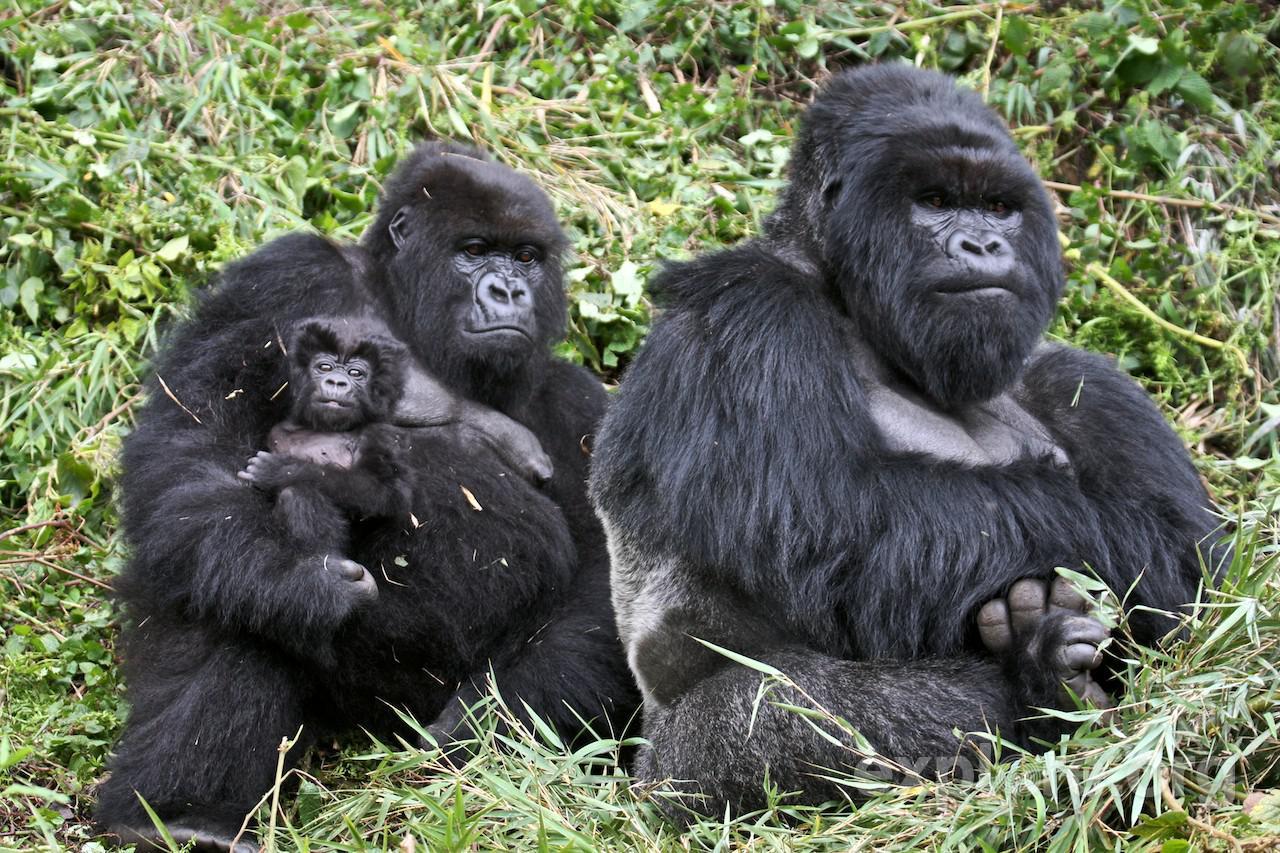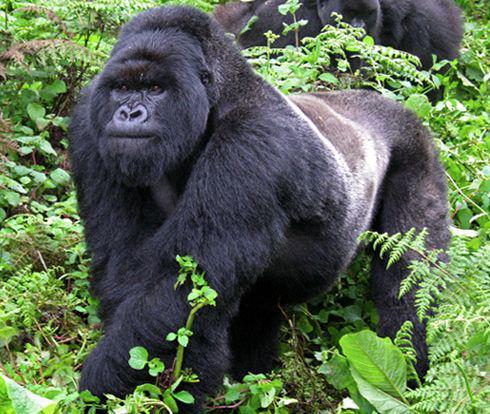The first image is the image on the left, the second image is the image on the right. Assess this claim about the two images: "An image includes a baby gorilla with at least one adult gorilla.". Correct or not? Answer yes or no. Yes. The first image is the image on the left, the second image is the image on the right. Given the left and right images, does the statement "A baby gorilla is being carried by its mother." hold true? Answer yes or no. Yes. 